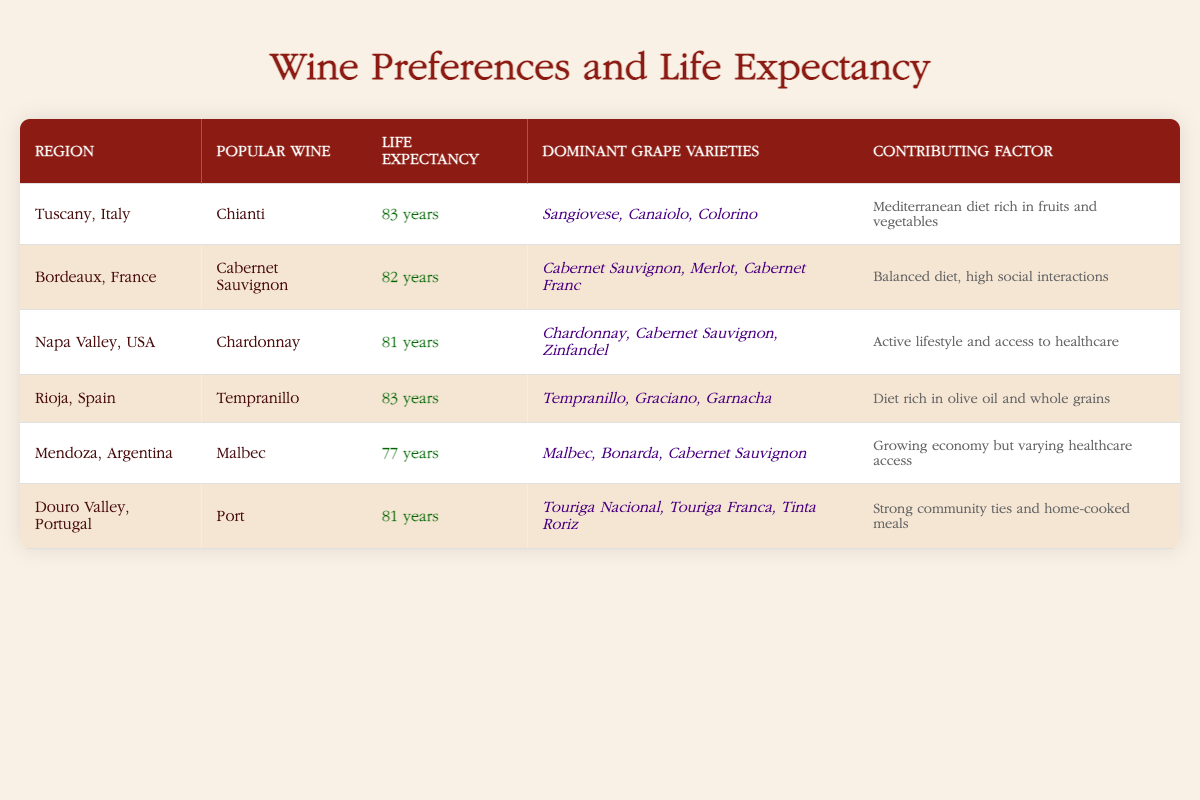What is the average life expectancy across all regions listed? To calculate the average life expectancy, we sum the life expectancies from all regions: (83 + 82 + 81 + 83 + 77 + 81) = 487. Since there are 6 regions, we divide the total by 6: 487 / 6 = 81.17, which we can round to 81 years.
Answer: 81 years Is the popular wine in Mendoza, Argentina associated with a higher life expectancy than that in Napa Valley, USA? Mendoza, Argentina has a life expectancy of 77 years with Malbec as the popular wine, whereas Napa Valley, USA has a higher life expectancy of 81 years with Chardonnay as the popular wine. Thus, Mendoza's life expectancy is lower than Napa's.
Answer: No What are the dominant grape varieties for Bordeaux, France, and are they similar to those in Tuscany, Italy? Bordeaux, France has dominant grape varieties of Cabernet Sauvignon, Merlot, and Cabernet Franc. In contrast, Tuscany, Italy’s dominant varieties are Sangiovese, Canaiolo, and Colorino. They are not similar as they belong to different grape varietal categories.
Answer: No What is the contributing factor for the life expectancy of consumers in the Douro Valley, Portugal? The contributing factor for the Douro Valley, Portugal is described as strong community ties and home-cooked meals. This suggests that social connections and traditional diets play a role in their life expectancy.
Answer: Strong community ties and home-cooked meals 